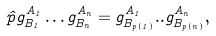<formula> <loc_0><loc_0><loc_500><loc_500>\hat { p } g ^ { A _ { 1 } } _ { B _ { 1 } } \dots g ^ { A _ { n } } _ { B _ { n } } = g ^ { A _ { 1 } } _ { B _ { p ( 1 ) } } . . g ^ { A _ { n } } _ { B _ { p ( n ) } } ,</formula> 